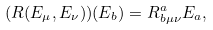<formula> <loc_0><loc_0><loc_500><loc_500>( R ( E _ { \mu } , E _ { \nu } ) ) ( E _ { b } ) = R _ { b \mu \nu } ^ { a } E _ { a } ,</formula> 